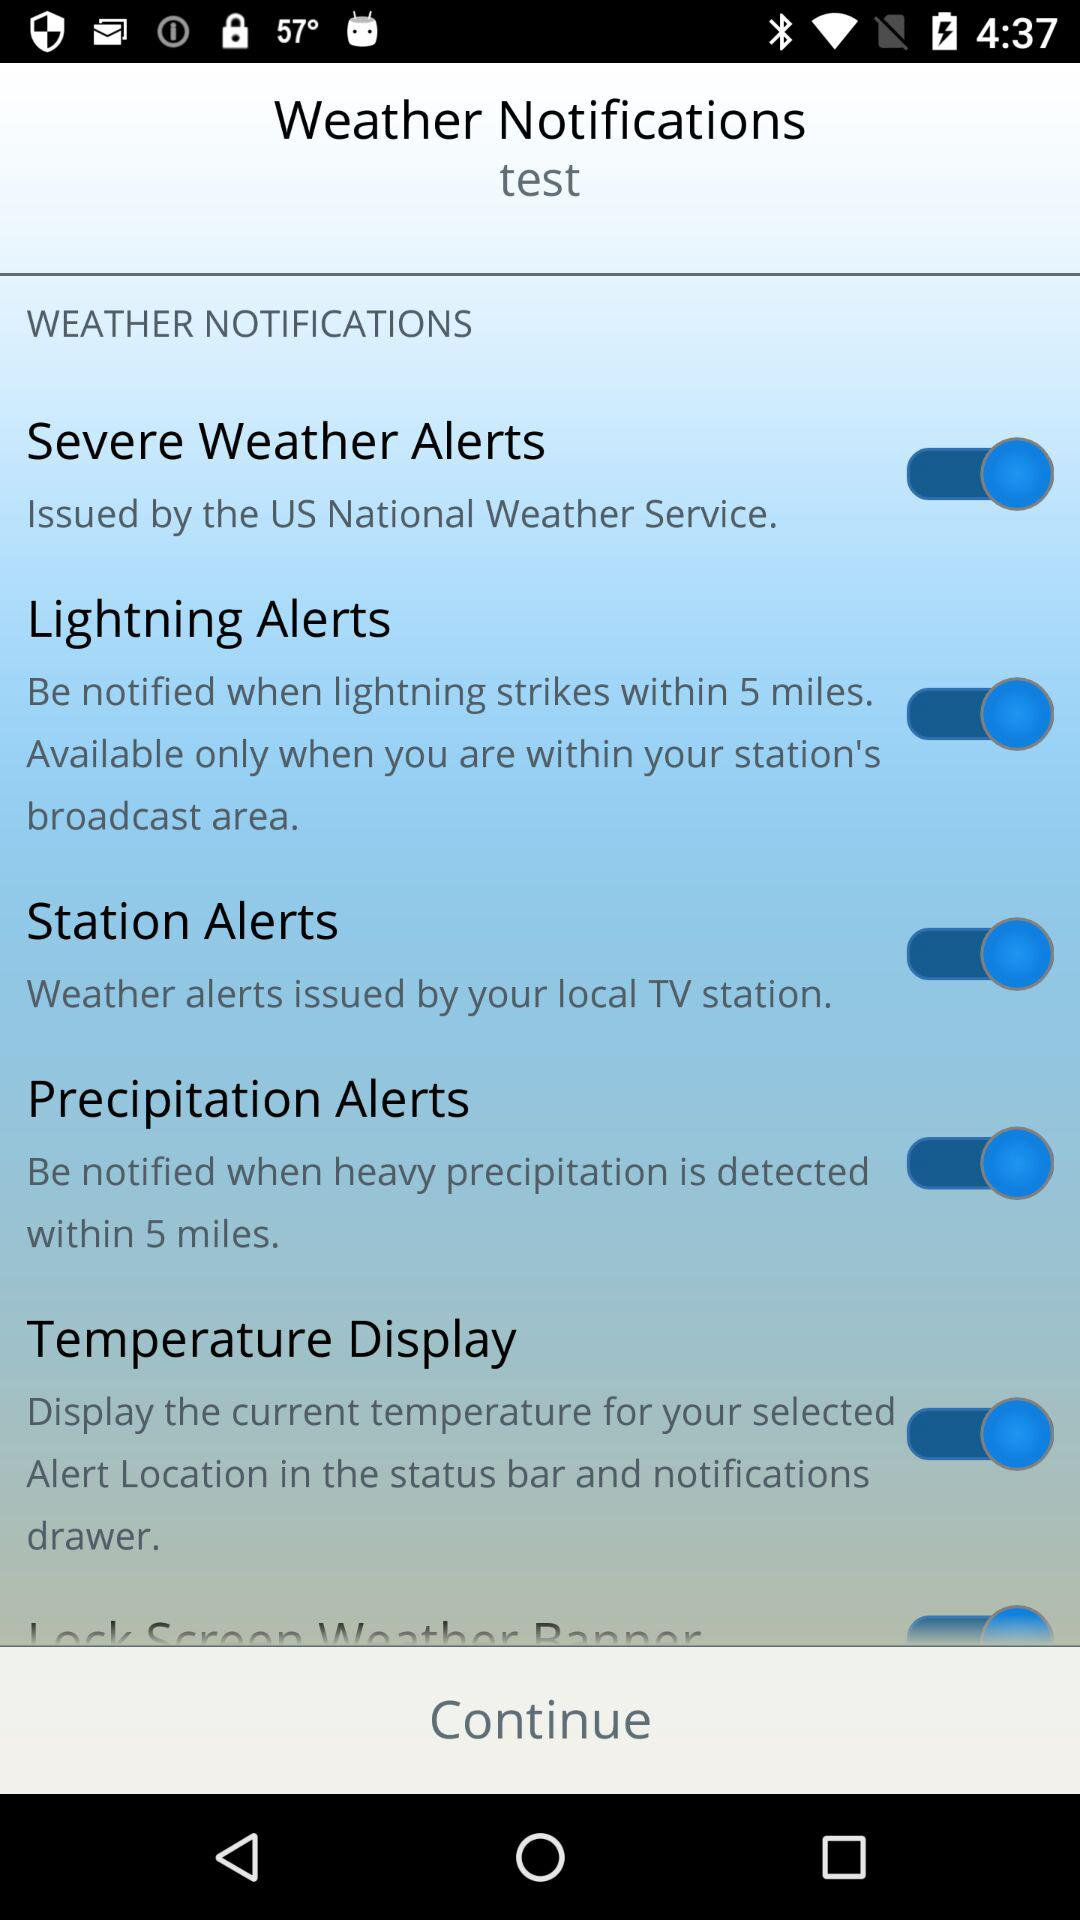Is "WEATHER NOTIFICATIONS" checked or not checked?
When the provided information is insufficient, respond with <no answer>. <no answer> 